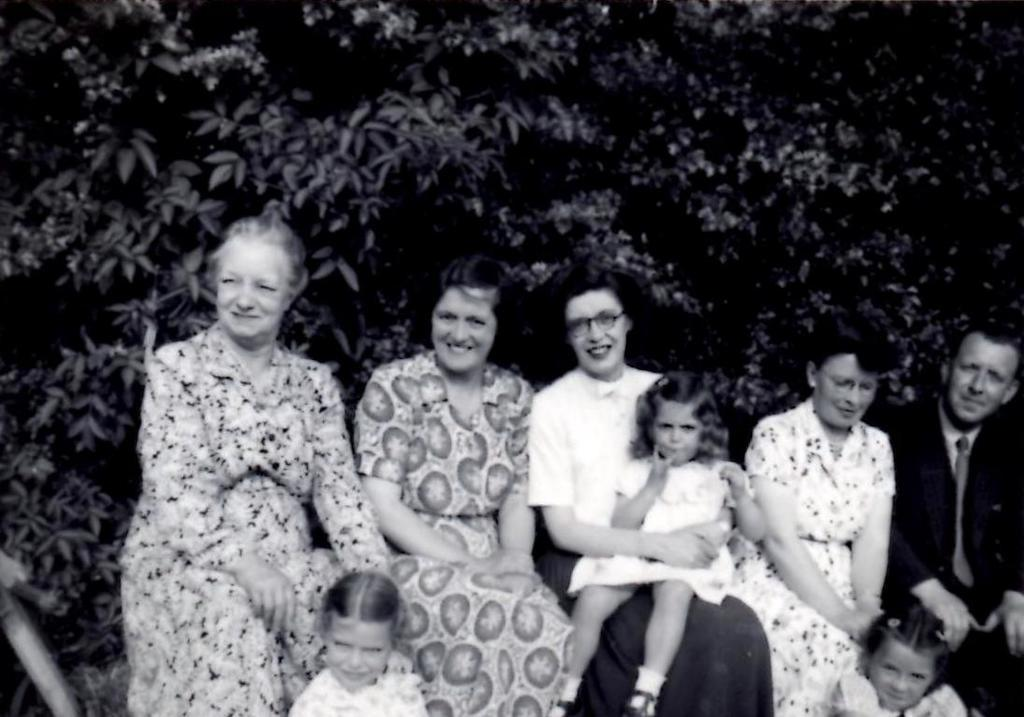What is the color scheme of the image? The image is black and white. Who can be seen in the image? There are people and children in the image. What are the people and children doing in the image? They are sitting and smiling. What can be seen in the background of the image? There are trees in the background of the image. How many bikes are visible in the image? There are no bikes present in the image. Are the children in the image brothers? The relationship between the children cannot be determined from the image. Can you see a mitten in the image? There is no mitten present in the image. 